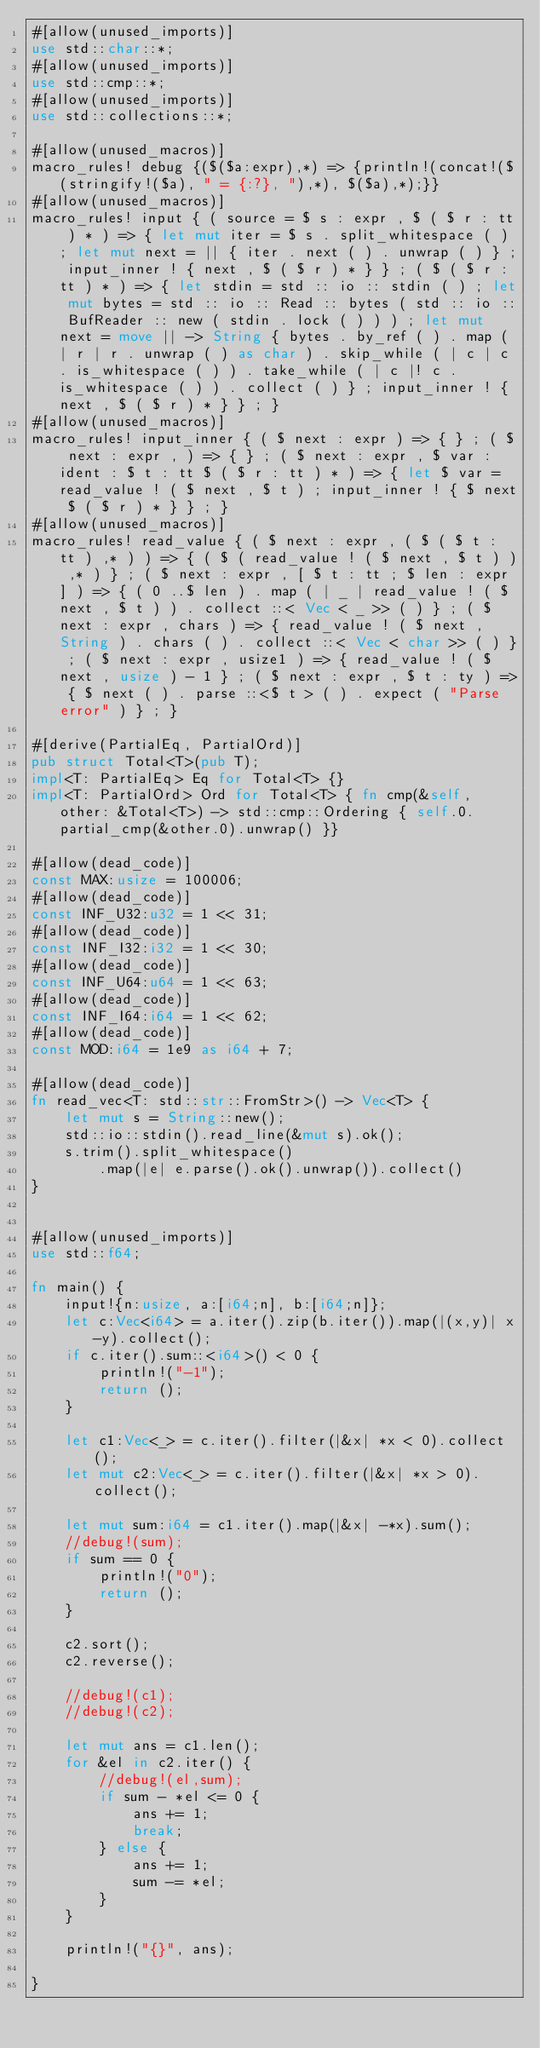<code> <loc_0><loc_0><loc_500><loc_500><_Rust_>#[allow(unused_imports)]
use std::char::*;
#[allow(unused_imports)]
use std::cmp::*;
#[allow(unused_imports)]
use std::collections::*;

#[allow(unused_macros)]
macro_rules! debug {($($a:expr),*) => {println!(concat!($(stringify!($a), " = {:?}, "),*), $($a),*);}}
#[allow(unused_macros)]
macro_rules! input { ( source = $ s : expr , $ ( $ r : tt ) * ) => { let mut iter = $ s . split_whitespace ( ) ; let mut next = || { iter . next ( ) . unwrap ( ) } ; input_inner ! { next , $ ( $ r ) * } } ; ( $ ( $ r : tt ) * ) => { let stdin = std :: io :: stdin ( ) ; let mut bytes = std :: io :: Read :: bytes ( std :: io :: BufReader :: new ( stdin . lock ( ) ) ) ; let mut next = move || -> String { bytes . by_ref ( ) . map ( | r | r . unwrap ( ) as char ) . skip_while ( | c | c . is_whitespace ( ) ) . take_while ( | c |! c . is_whitespace ( ) ) . collect ( ) } ; input_inner ! { next , $ ( $ r ) * } } ; }
#[allow(unused_macros)]
macro_rules! input_inner { ( $ next : expr ) => { } ; ( $ next : expr , ) => { } ; ( $ next : expr , $ var : ident : $ t : tt $ ( $ r : tt ) * ) => { let $ var = read_value ! ( $ next , $ t ) ; input_inner ! { $ next $ ( $ r ) * } } ; }
#[allow(unused_macros)]
macro_rules! read_value { ( $ next : expr , ( $ ( $ t : tt ) ,* ) ) => { ( $ ( read_value ! ( $ next , $ t ) ) ,* ) } ; ( $ next : expr , [ $ t : tt ; $ len : expr ] ) => { ( 0 ..$ len ) . map ( | _ | read_value ! ( $ next , $ t ) ) . collect ::< Vec < _ >> ( ) } ; ( $ next : expr , chars ) => { read_value ! ( $ next , String ) . chars ( ) . collect ::< Vec < char >> ( ) } ; ( $ next : expr , usize1 ) => { read_value ! ( $ next , usize ) - 1 } ; ( $ next : expr , $ t : ty ) => { $ next ( ) . parse ::<$ t > ( ) . expect ( "Parse error" ) } ; }

#[derive(PartialEq, PartialOrd)]
pub struct Total<T>(pub T);
impl<T: PartialEq> Eq for Total<T> {}
impl<T: PartialOrd> Ord for Total<T> { fn cmp(&self, other: &Total<T>) -> std::cmp::Ordering { self.0.partial_cmp(&other.0).unwrap() }}

#[allow(dead_code)]
const MAX:usize = 100006;
#[allow(dead_code)]
const INF_U32:u32 = 1 << 31;
#[allow(dead_code)]
const INF_I32:i32 = 1 << 30;
#[allow(dead_code)]
const INF_U64:u64 = 1 << 63;
#[allow(dead_code)]
const INF_I64:i64 = 1 << 62;
#[allow(dead_code)]
const MOD:i64 = 1e9 as i64 + 7;

#[allow(dead_code)]
fn read_vec<T: std::str::FromStr>() -> Vec<T> {
    let mut s = String::new();
    std::io::stdin().read_line(&mut s).ok();
    s.trim().split_whitespace()
        .map(|e| e.parse().ok().unwrap()).collect()
}


#[allow(unused_imports)]
use std::f64;

fn main() {
    input!{n:usize, a:[i64;n], b:[i64;n]};
    let c:Vec<i64> = a.iter().zip(b.iter()).map(|(x,y)| x-y).collect();
    if c.iter().sum::<i64>() < 0 {
        println!("-1");
        return ();
    }

    let c1:Vec<_> = c.iter().filter(|&x| *x < 0).collect();
    let mut c2:Vec<_> = c.iter().filter(|&x| *x > 0).collect();

    let mut sum:i64 = c1.iter().map(|&x| -*x).sum();
    //debug!(sum);
    if sum == 0 {
        println!("0");
        return ();
    }

    c2.sort();
    c2.reverse();

    //debug!(c1);
    //debug!(c2);

    let mut ans = c1.len();
    for &el in c2.iter() {
        //debug!(el,sum);
        if sum - *el <= 0 {
            ans += 1;
            break;
        } else {
            ans += 1;
            sum -= *el;
        }
    }

    println!("{}", ans);

}</code> 